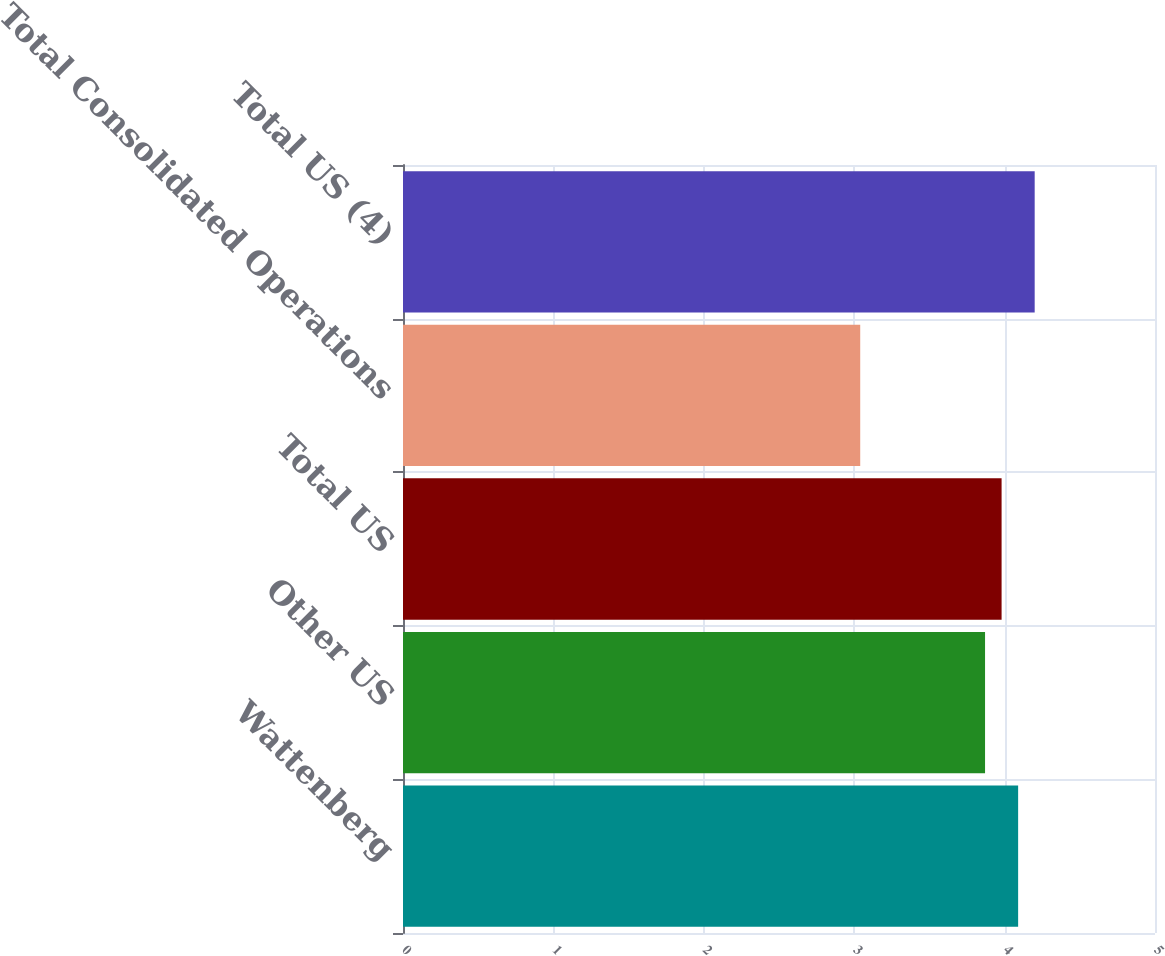Convert chart. <chart><loc_0><loc_0><loc_500><loc_500><bar_chart><fcel>Wattenberg<fcel>Other US<fcel>Total US<fcel>Total Consolidated Operations<fcel>Total US (4)<nl><fcel>4.09<fcel>3.87<fcel>3.98<fcel>3.04<fcel>4.2<nl></chart> 